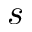Convert formula to latex. <formula><loc_0><loc_0><loc_500><loc_500>s</formula> 